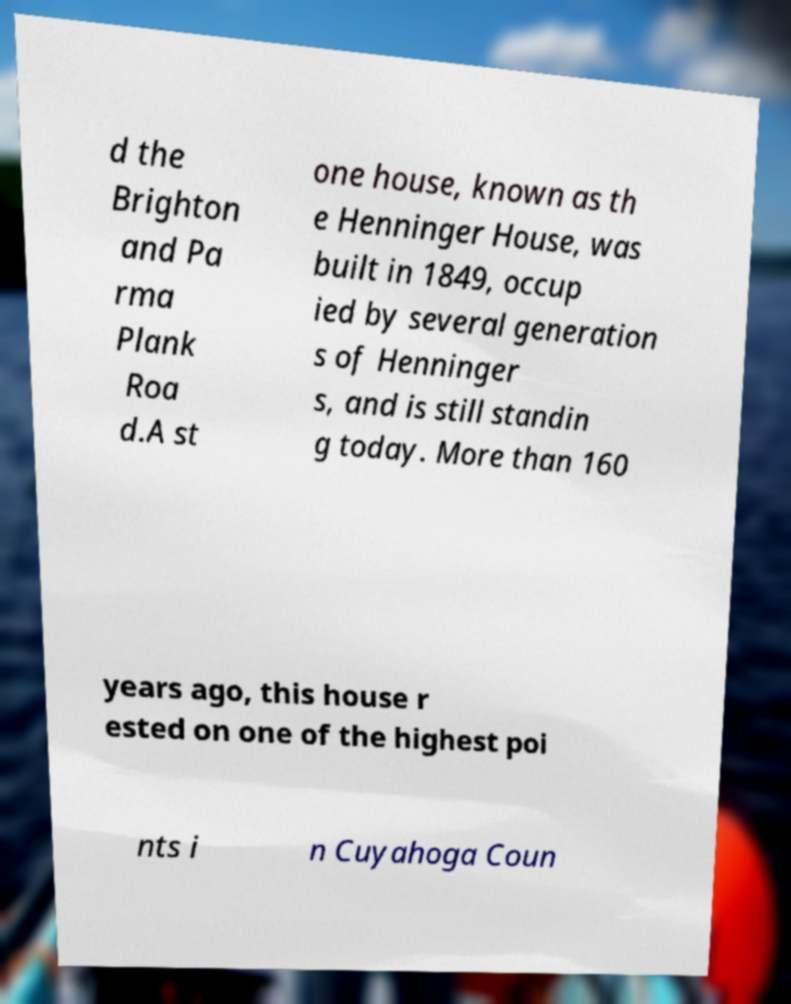I need the written content from this picture converted into text. Can you do that? d the Brighton and Pa rma Plank Roa d.A st one house, known as th e Henninger House, was built in 1849, occup ied by several generation s of Henninger s, and is still standin g today. More than 160 years ago, this house r ested on one of the highest poi nts i n Cuyahoga Coun 